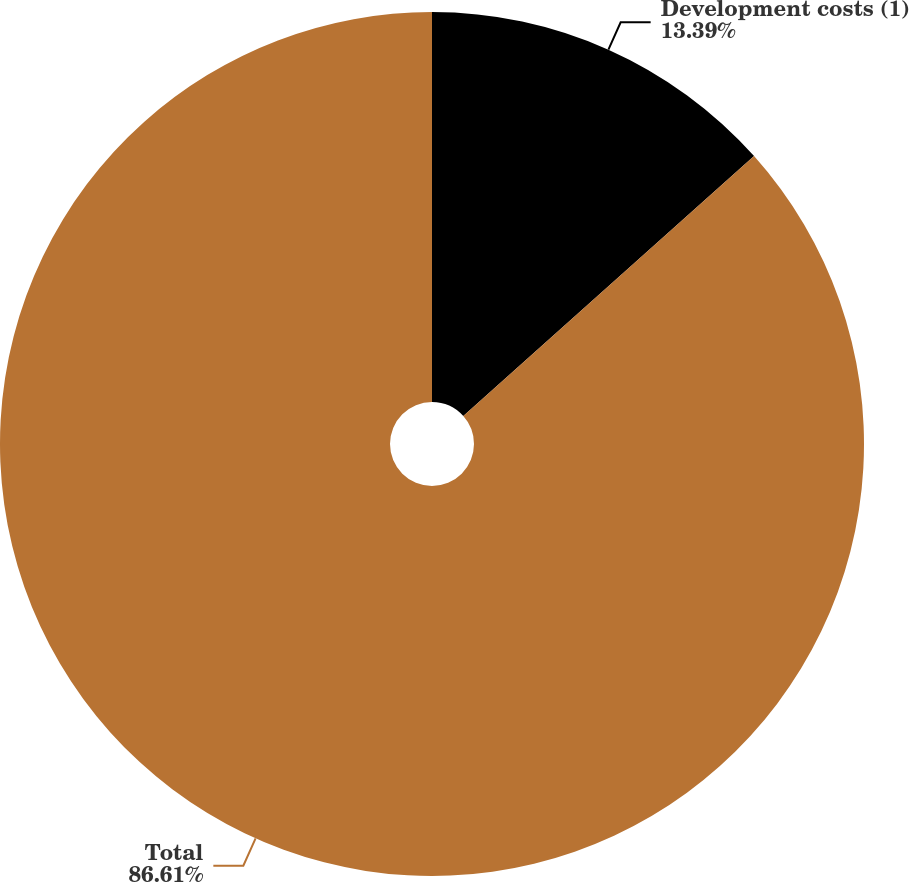<chart> <loc_0><loc_0><loc_500><loc_500><pie_chart><fcel>Development costs (1)<fcel>Total<nl><fcel>13.39%<fcel>86.61%<nl></chart> 